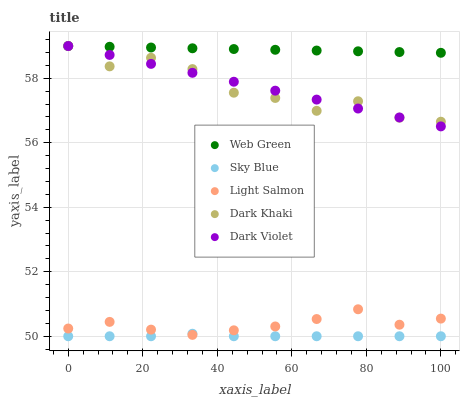Does Sky Blue have the minimum area under the curve?
Answer yes or no. Yes. Does Web Green have the maximum area under the curve?
Answer yes or no. Yes. Does Light Salmon have the minimum area under the curve?
Answer yes or no. No. Does Light Salmon have the maximum area under the curve?
Answer yes or no. No. Is Dark Violet the smoothest?
Answer yes or no. Yes. Is Dark Khaki the roughest?
Answer yes or no. Yes. Is Sky Blue the smoothest?
Answer yes or no. No. Is Sky Blue the roughest?
Answer yes or no. No. Does Sky Blue have the lowest value?
Answer yes or no. Yes. Does Light Salmon have the lowest value?
Answer yes or no. No. Does Web Green have the highest value?
Answer yes or no. Yes. Does Light Salmon have the highest value?
Answer yes or no. No. Is Light Salmon less than Web Green?
Answer yes or no. Yes. Is Dark Khaki greater than Sky Blue?
Answer yes or no. Yes. Does Light Salmon intersect Sky Blue?
Answer yes or no. Yes. Is Light Salmon less than Sky Blue?
Answer yes or no. No. Is Light Salmon greater than Sky Blue?
Answer yes or no. No. Does Light Salmon intersect Web Green?
Answer yes or no. No. 